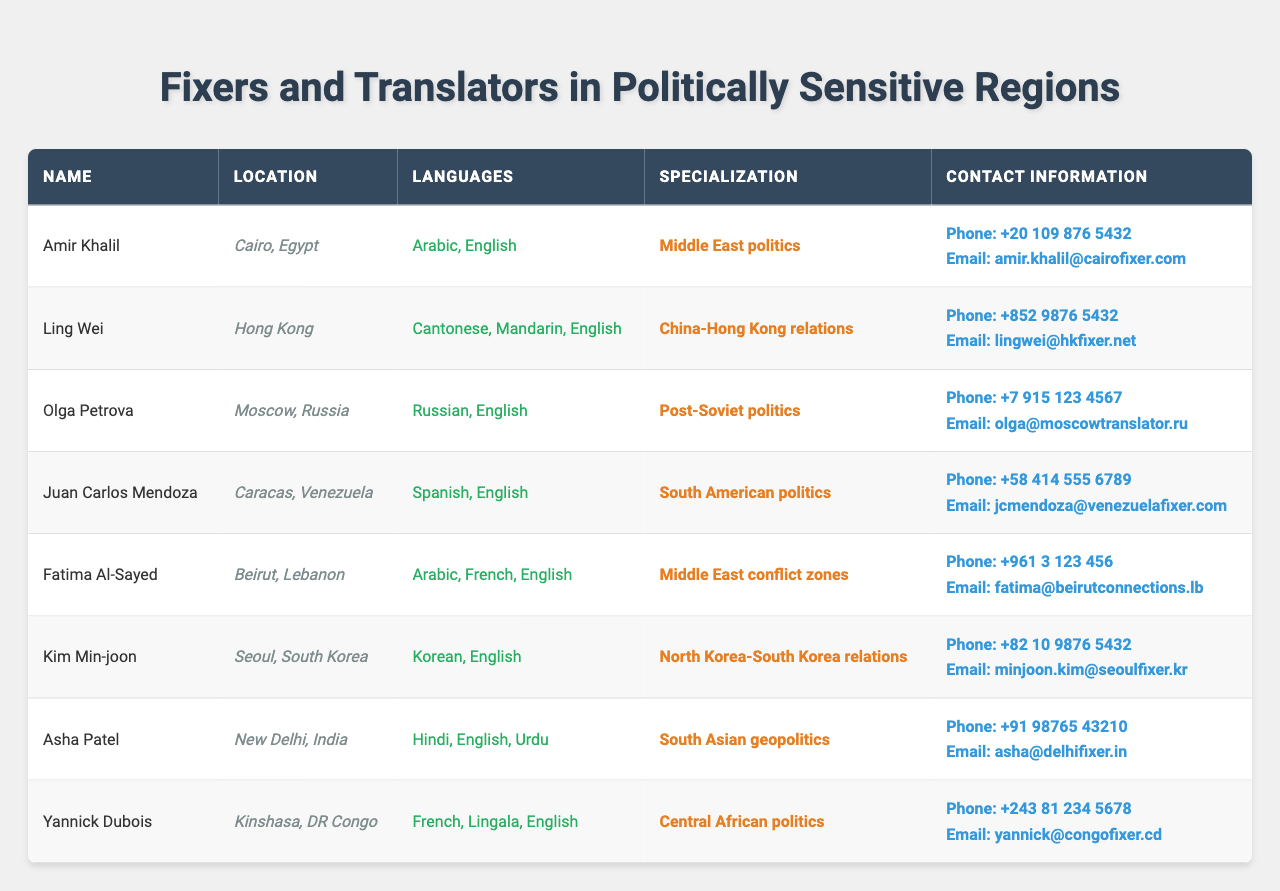What is the phone number of Amir Khalil? The table lists Amir Khalil's contact information, which includes the phone number "+20 109 876 5432".
Answer: +20 109 876 5432 How many different languages does Fatima Al-Sayed speak? Fatima Al-Sayed speaks three languages: Arabic, French, and English, as stated in the languages column.
Answer: Three What is the specialization of Ling Wei? The table specifies that Ling Wei's specialization is "China-Hong Kong relations".
Answer: China-Hong Kong relations Is Juan Carlos Mendoza located in Caracas, Venezuela? The table indicates that Juan Carlos Mendoza is indeed located in Caracas, Venezuela, as per the location column.
Answer: Yes Which fixer speaks Russian and English? Referring to the languages column, it is evident that Olga Petrova speaks both Russian and English.
Answer: Olga Petrova Who are the fixers located in Middle Eastern regions? From the table, there are two fixers in Middle Eastern regions: Amir Khalil from Cairo and Fatima Al-Sayed from Beirut.
Answer: Amir Khalil and Fatima Al-Sayed Among the listed fixers, who has a specialization in South American politics? The table notes that Juan Carlos Mendoza specializes in South American politics, allowing for the identification of this specialization.
Answer: Juan Carlos Mendoza What is the total number of fixers who speak English? By examining the languages column, we can see that all eight fixers speak English, as it is listed for each one.
Answer: Eight Who has the contact email "asha@delhifixer.in"? The table shows that Asha Patel's email is listed as "asha@delhifixer.in" in the contact information section.
Answer: Asha Patel Which fixer is based in Seoul, South Korea? The location column states that Kim Min-joon is based in Seoul, South Korea, providing the necessary information.
Answer: Kim Min-joon What is the average number of languages spoken by the fixers listed? A count of languages shows Amir speaks 2, Ling 3, Olga 2, Juan 2, Fatima 3, Kim 2, Asha 3, and Yannick 3, summing to 20 languages. Dividing by 8 fixers gives an average of 20/8 = 2.5.
Answer: 2.5 